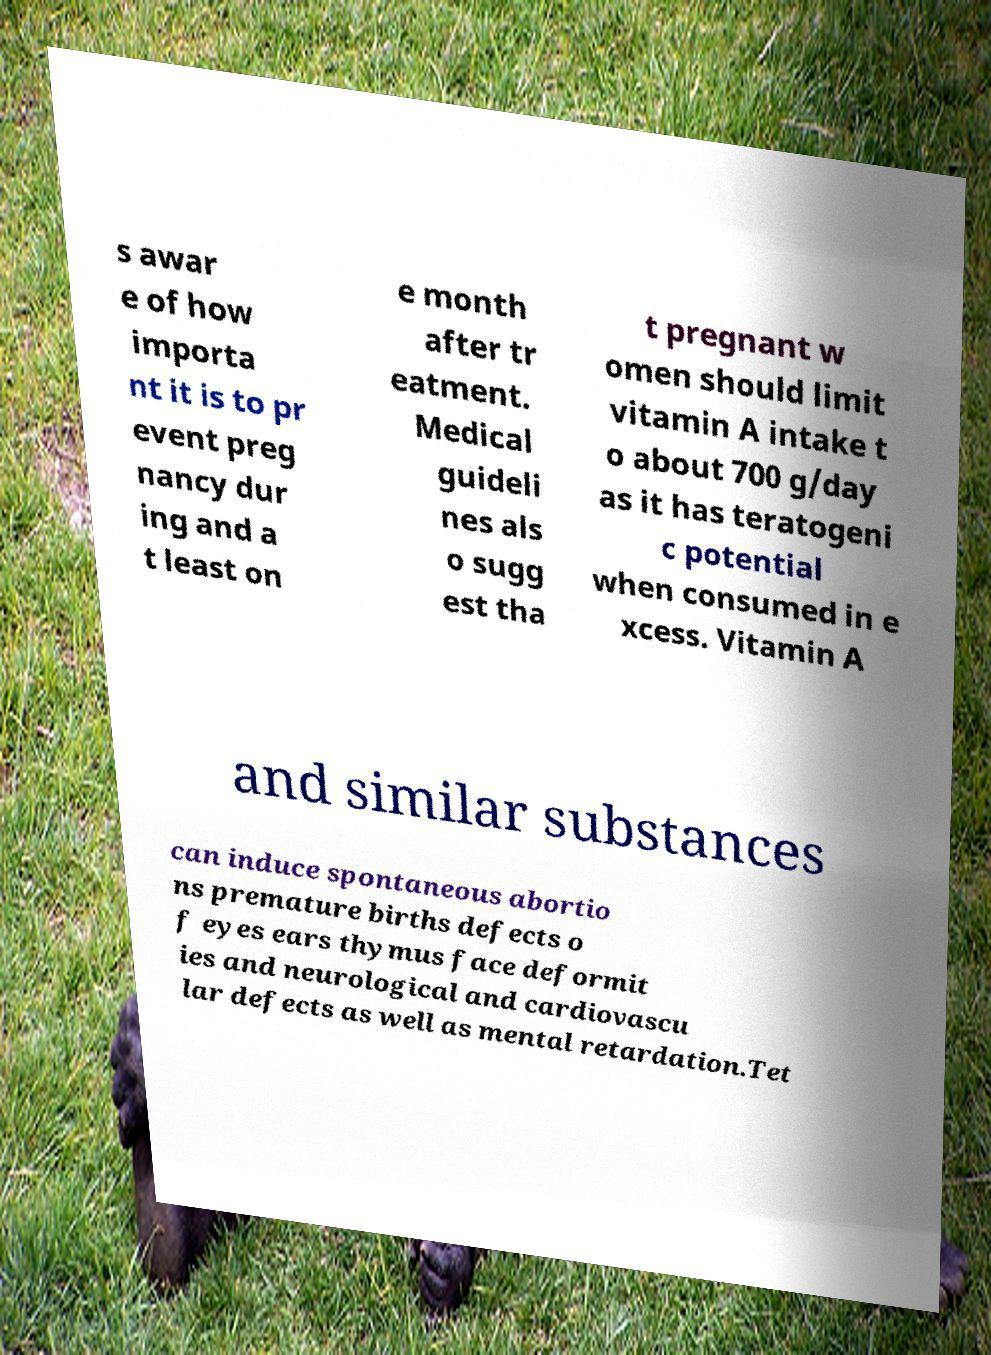Can you read and provide the text displayed in the image?This photo seems to have some interesting text. Can you extract and type it out for me? s awar e of how importa nt it is to pr event preg nancy dur ing and a t least on e month after tr eatment. Medical guideli nes als o sugg est tha t pregnant w omen should limit vitamin A intake t o about 700 g/day as it has teratogeni c potential when consumed in e xcess. Vitamin A and similar substances can induce spontaneous abortio ns premature births defects o f eyes ears thymus face deformit ies and neurological and cardiovascu lar defects as well as mental retardation.Tet 